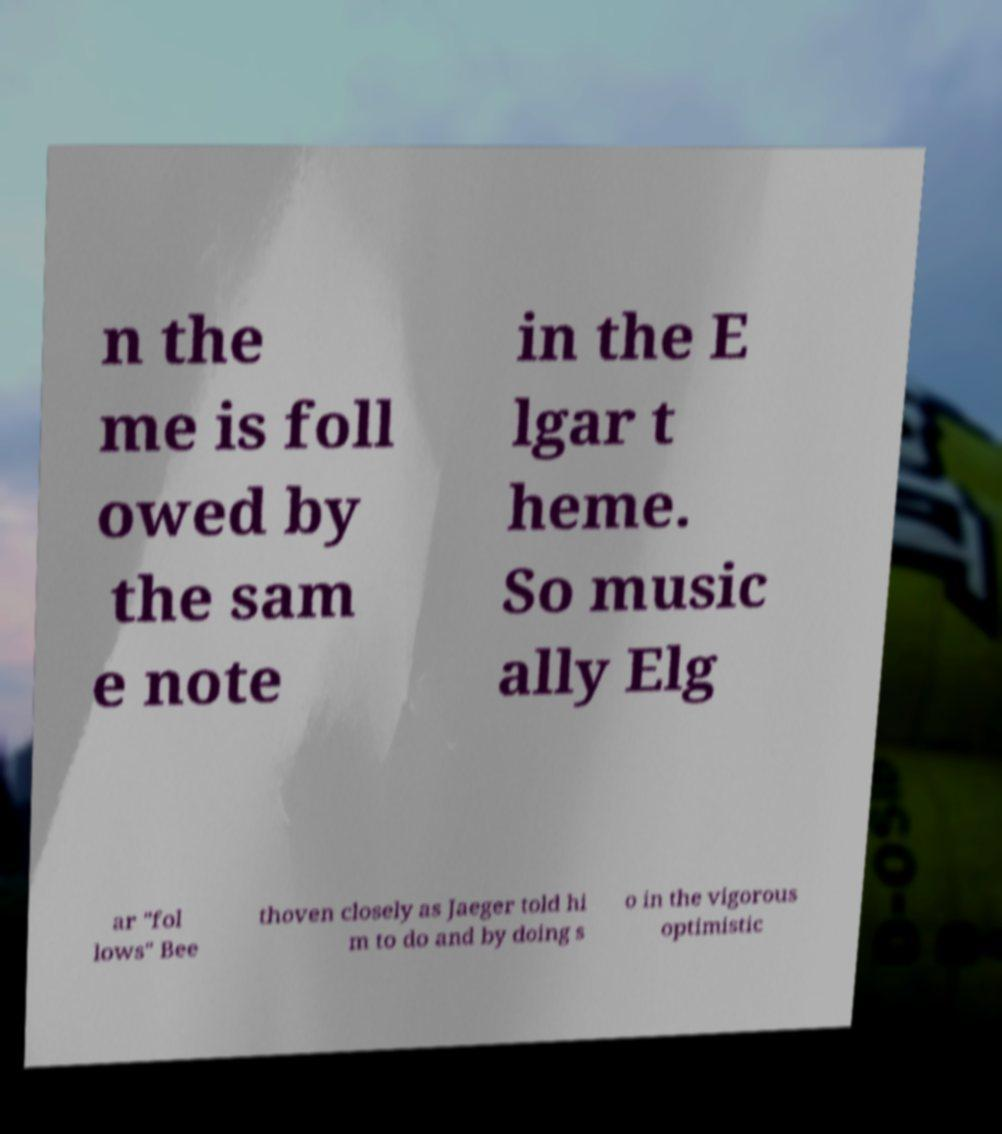Please read and relay the text visible in this image. What does it say? n the me is foll owed by the sam e note in the E lgar t heme. So music ally Elg ar "fol lows" Bee thoven closely as Jaeger told hi m to do and by doing s o in the vigorous optimistic 